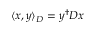Convert formula to latex. <formula><loc_0><loc_0><loc_500><loc_500>\langle x , y \rangle _ { D } = y ^ { \dagger } D x</formula> 